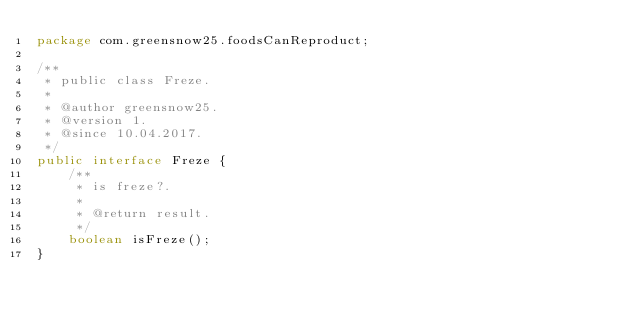<code> <loc_0><loc_0><loc_500><loc_500><_Java_>package com.greensnow25.foodsCanReproduct;

/**
 * public class Freze.
 *
 * @author greensnow25.
 * @version 1.
 * @since 10.04.2017.
 */
public interface Freze {
    /**
     * is freze?.
     *
     * @return result.
     */
    boolean isFreze();
}
</code> 